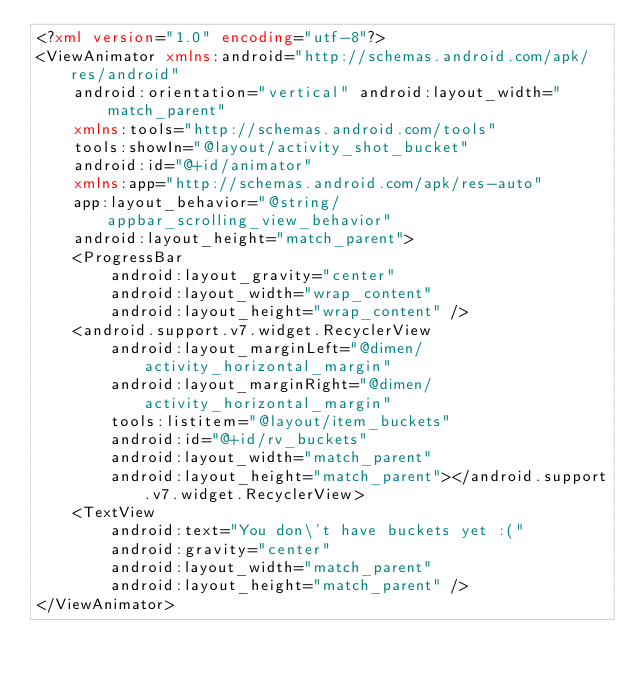<code> <loc_0><loc_0><loc_500><loc_500><_XML_><?xml version="1.0" encoding="utf-8"?>
<ViewAnimator xmlns:android="http://schemas.android.com/apk/res/android"
    android:orientation="vertical" android:layout_width="match_parent"
    xmlns:tools="http://schemas.android.com/tools"
    tools:showIn="@layout/activity_shot_bucket"
    android:id="@+id/animator"
    xmlns:app="http://schemas.android.com/apk/res-auto"
    app:layout_behavior="@string/appbar_scrolling_view_behavior"
    android:layout_height="match_parent">
    <ProgressBar
        android:layout_gravity="center"
        android:layout_width="wrap_content"
        android:layout_height="wrap_content" />
    <android.support.v7.widget.RecyclerView
        android:layout_marginLeft="@dimen/activity_horizontal_margin"
        android:layout_marginRight="@dimen/activity_horizontal_margin"
        tools:listitem="@layout/item_buckets"
        android:id="@+id/rv_buckets"
        android:layout_width="match_parent"
        android:layout_height="match_parent"></android.support.v7.widget.RecyclerView>
    <TextView
        android:text="You don\'t have buckets yet :("
        android:gravity="center"
        android:layout_width="match_parent"
        android:layout_height="match_parent" />
</ViewAnimator></code> 